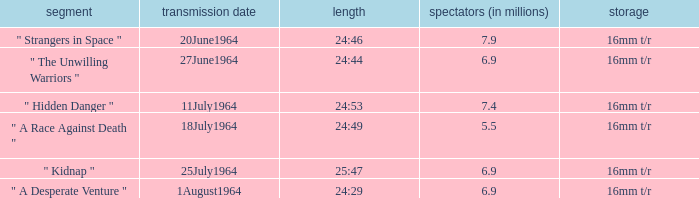What episode aired on 11july1964? " Hidden Danger ". 